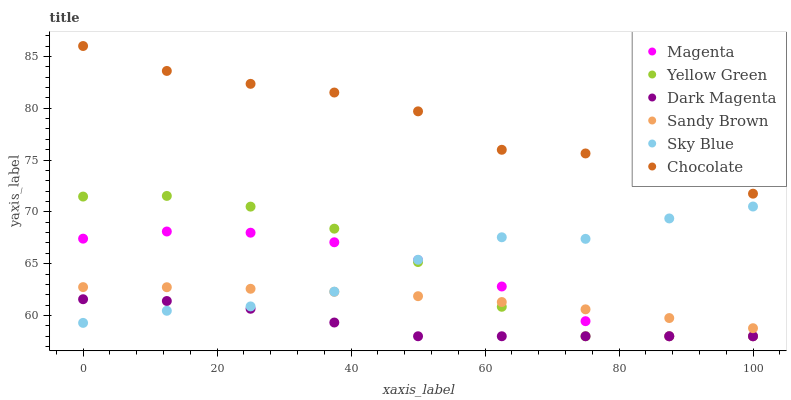Does Dark Magenta have the minimum area under the curve?
Answer yes or no. Yes. Does Chocolate have the maximum area under the curve?
Answer yes or no. Yes. Does Sky Blue have the minimum area under the curve?
Answer yes or no. No. Does Sky Blue have the maximum area under the curve?
Answer yes or no. No. Is Sandy Brown the smoothest?
Answer yes or no. Yes. Is Chocolate the roughest?
Answer yes or no. Yes. Is Sky Blue the smoothest?
Answer yes or no. No. Is Sky Blue the roughest?
Answer yes or no. No. Does Yellow Green have the lowest value?
Answer yes or no. Yes. Does Sky Blue have the lowest value?
Answer yes or no. No. Does Chocolate have the highest value?
Answer yes or no. Yes. Does Sky Blue have the highest value?
Answer yes or no. No. Is Magenta less than Chocolate?
Answer yes or no. Yes. Is Chocolate greater than Yellow Green?
Answer yes or no. Yes. Does Yellow Green intersect Sandy Brown?
Answer yes or no. Yes. Is Yellow Green less than Sandy Brown?
Answer yes or no. No. Is Yellow Green greater than Sandy Brown?
Answer yes or no. No. Does Magenta intersect Chocolate?
Answer yes or no. No. 